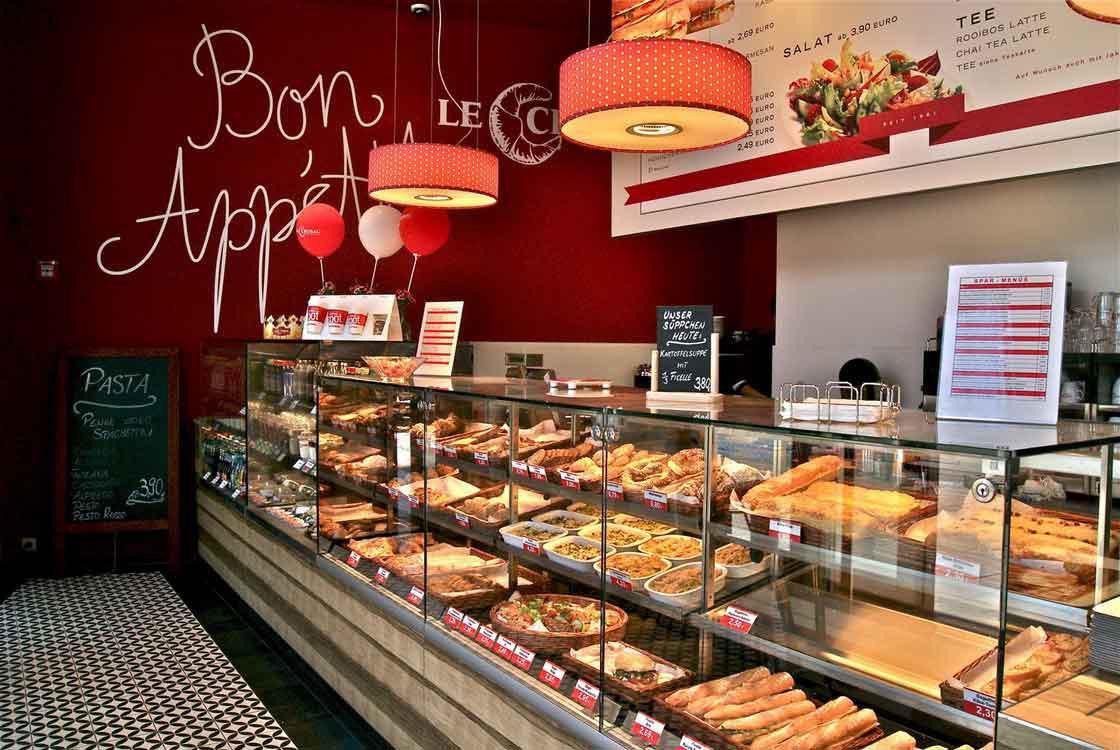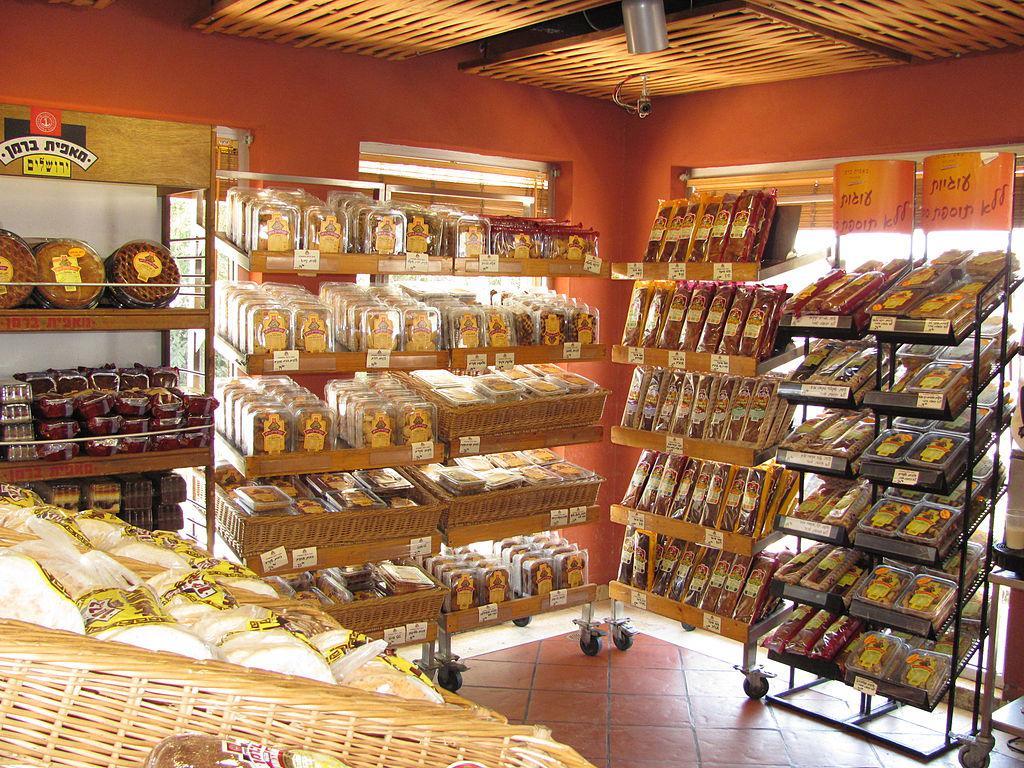The first image is the image on the left, the second image is the image on the right. Assess this claim about the two images: "The decor of one bakery features a colorful suspended light with a round shape.". Correct or not? Answer yes or no. Yes. The first image is the image on the left, the second image is the image on the right. Considering the images on both sides, is "A bakery in one image has a seating area with tables and chairs where patrons can sit and enjoy the food and drinks they buy." valid? Answer yes or no. No. 